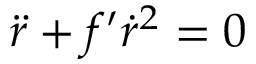Convert formula to latex. <formula><loc_0><loc_0><loc_500><loc_500>\ddot { r } + f ^ { \prime } \dot { r } ^ { 2 } = 0</formula> 